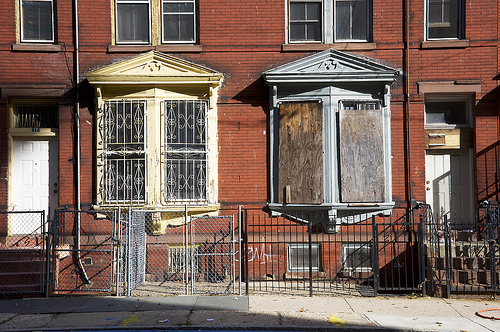<image>
Can you confirm if the window is to the right of the door? Yes. From this viewpoint, the window is positioned to the right side relative to the door. 